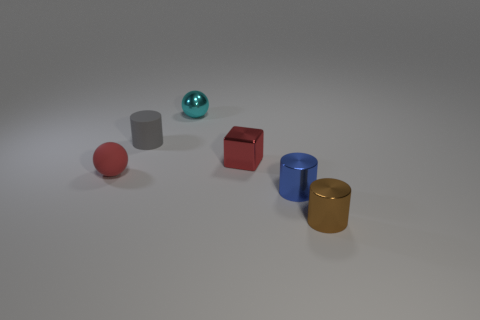Add 2 red metal objects. How many objects exist? 8 Subtract all shiny cylinders. How many cylinders are left? 1 Subtract all red balls. How many balls are left? 1 Subtract all spheres. How many objects are left? 4 Add 2 tiny matte cylinders. How many tiny matte cylinders are left? 3 Add 3 cubes. How many cubes exist? 4 Subtract 0 blue balls. How many objects are left? 6 Subtract 2 spheres. How many spheres are left? 0 Subtract all green cylinders. Subtract all brown balls. How many cylinders are left? 3 Subtract all big cyan things. Subtract all small blocks. How many objects are left? 5 